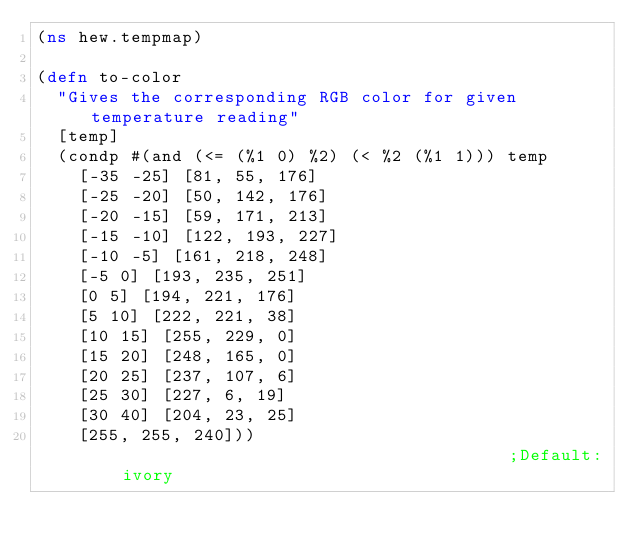Convert code to text. <code><loc_0><loc_0><loc_500><loc_500><_Clojure_>(ns hew.tempmap)

(defn to-color
  "Gives the corresponding RGB color for given temperature reading"
  [temp]
  (condp #(and (<= (%1 0) %2) (< %2 (%1 1))) temp
    [-35 -25] [81, 55, 176]
    [-25 -20] [50, 142, 176]
    [-20 -15] [59, 171, 213]
    [-15 -10] [122, 193, 227]
    [-10 -5] [161, 218, 248]
    [-5 0] [193, 235, 251]
    [0 5] [194, 221, 176]
    [5 10] [222, 221, 38]
    [10 15] [255, 229, 0]
    [15 20] [248, 165, 0]
    [20 25] [237, 107, 6]
    [25 30] [227, 6, 19]
    [30 40] [204, 23, 25]
    [255, 255, 240]))                                       ;Default: ivory


</code> 